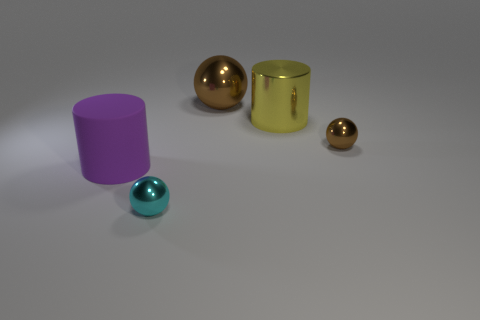Subtract all brown balls. How many balls are left? 1 Add 4 purple matte cylinders. How many objects exist? 9 Subtract all brown balls. How many balls are left? 1 Subtract 3 spheres. How many spheres are left? 0 Subtract all brown cylinders. How many cyan spheres are left? 1 Subtract all small cyan blocks. Subtract all big metallic things. How many objects are left? 3 Add 2 shiny cylinders. How many shiny cylinders are left? 3 Add 1 big yellow metal cylinders. How many big yellow metal cylinders exist? 2 Subtract 1 purple cylinders. How many objects are left? 4 Subtract all balls. How many objects are left? 2 